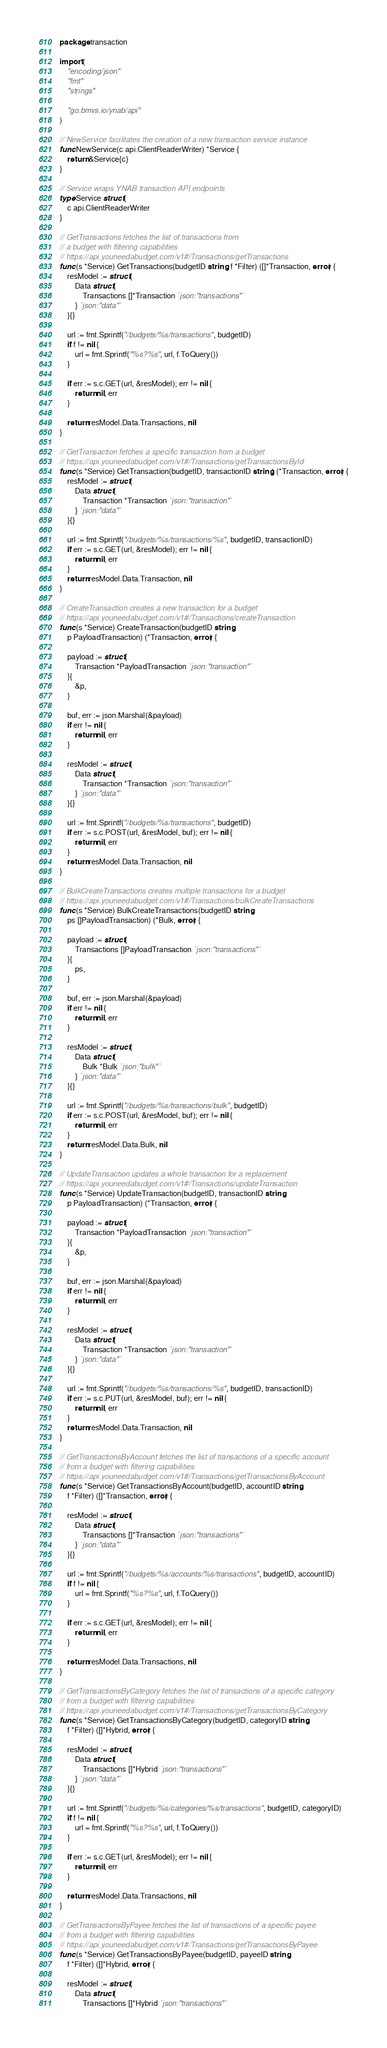Convert code to text. <code><loc_0><loc_0><loc_500><loc_500><_Go_>package transaction

import (
	"encoding/json"
	"fmt"
	"strings"

	"go.bmvs.io/ynab/api"
)

// NewService facilitates the creation of a new transaction service instance
func NewService(c api.ClientReaderWriter) *Service {
	return &Service{c}
}

// Service wraps YNAB transaction API endpoints
type Service struct {
	c api.ClientReaderWriter
}

// GetTransactions fetches the list of transactions from
// a budget with filtering capabilities
// https://api.youneedabudget.com/v1#/Transactions/getTransactions
func (s *Service) GetTransactions(budgetID string, f *Filter) ([]*Transaction, error) {
	resModel := struct {
		Data struct {
			Transactions []*Transaction `json:"transactions"`
		} `json:"data"`
	}{}

	url := fmt.Sprintf("/budgets/%s/transactions", budgetID)
	if f != nil {
		url = fmt.Sprintf("%s?%s", url, f.ToQuery())
	}

	if err := s.c.GET(url, &resModel); err != nil {
		return nil, err
	}

	return resModel.Data.Transactions, nil
}

// GetTransaction fetches a specific transaction from a budget
// https://api.youneedabudget.com/v1#/Transactions/getTransactionsById
func (s *Service) GetTransaction(budgetID, transactionID string) (*Transaction, error) {
	resModel := struct {
		Data struct {
			Transaction *Transaction `json:"transaction"`
		} `json:"data"`
	}{}

	url := fmt.Sprintf("/budgets/%s/transactions/%s", budgetID, transactionID)
	if err := s.c.GET(url, &resModel); err != nil {
		return nil, err
	}
	return resModel.Data.Transaction, nil
}

// CreateTransaction creates a new transaction for a budget
// https://api.youneedabudget.com/v1#/Transactions/createTransaction
func (s *Service) CreateTransaction(budgetID string,
	p PayloadTransaction) (*Transaction, error) {

	payload := struct {
		Transaction *PayloadTransaction `json:"transaction"`
	}{
		&p,
	}

	buf, err := json.Marshal(&payload)
	if err != nil {
		return nil, err
	}

	resModel := struct {
		Data struct {
			Transaction *Transaction `json:"transaction"`
		} `json:"data"`
	}{}

	url := fmt.Sprintf("/budgets/%s/transactions", budgetID)
	if err := s.c.POST(url, &resModel, buf); err != nil {
		return nil, err
	}
	return resModel.Data.Transaction, nil
}

// BulkCreateTransactions creates multiple transactions for a budget
// https://api.youneedabudget.com/v1#/Transactions/bulkCreateTransactions
func (s *Service) BulkCreateTransactions(budgetID string,
	ps []PayloadTransaction) (*Bulk, error) {

	payload := struct {
		Transactions []PayloadTransaction `json:"transactions"`
	}{
		ps,
	}

	buf, err := json.Marshal(&payload)
	if err != nil {
		return nil, err
	}

	resModel := struct {
		Data struct {
			Bulk *Bulk `json:"bulk"`
		} `json:"data"`
	}{}

	url := fmt.Sprintf("/budgets/%s/transactions/bulk", budgetID)
	if err := s.c.POST(url, &resModel, buf); err != nil {
		return nil, err
	}
	return resModel.Data.Bulk, nil
}

// UpdateTransaction updates a whole transaction for a replacement
// https://api.youneedabudget.com/v1#/Transactions/updateTransaction
func (s *Service) UpdateTransaction(budgetID, transactionID string,
	p PayloadTransaction) (*Transaction, error) {

	payload := struct {
		Transaction *PayloadTransaction `json:"transaction"`
	}{
		&p,
	}

	buf, err := json.Marshal(&payload)
	if err != nil {
		return nil, err
	}

	resModel := struct {
		Data struct {
			Transaction *Transaction `json:"transaction"`
		} `json:"data"`
	}{}

	url := fmt.Sprintf("/budgets/%s/transactions/%s", budgetID, transactionID)
	if err := s.c.PUT(url, &resModel, buf); err != nil {
		return nil, err
	}
	return resModel.Data.Transaction, nil
}

// GetTransactionsByAccount fetches the list of transactions of a specific account
// from a budget with filtering capabilities
// https://api.youneedabudget.com/v1#/Transactions/getTransactionsByAccount
func (s *Service) GetTransactionsByAccount(budgetID, accountID string,
	f *Filter) ([]*Transaction, error) {

	resModel := struct {
		Data struct {
			Transactions []*Transaction `json:"transactions"`
		} `json:"data"`
	}{}

	url := fmt.Sprintf("/budgets/%s/accounts/%s/transactions", budgetID, accountID)
	if f != nil {
		url = fmt.Sprintf("%s?%s", url, f.ToQuery())
	}

	if err := s.c.GET(url, &resModel); err != nil {
		return nil, err
	}

	return resModel.Data.Transactions, nil
}

// GetTransactionsByCategory fetches the list of transactions of a specific category
// from a budget with filtering capabilities
// https://api.youneedabudget.com/v1#/Transactions/getTransactionsByCategory
func (s *Service) GetTransactionsByCategory(budgetID, categoryID string,
	f *Filter) ([]*Hybrid, error) {

	resModel := struct {
		Data struct {
			Transactions []*Hybrid `json:"transactions"`
		} `json:"data"`
	}{}

	url := fmt.Sprintf("/budgets/%s/categories/%s/transactions", budgetID, categoryID)
	if f != nil {
		url = fmt.Sprintf("%s?%s", url, f.ToQuery())
	}

	if err := s.c.GET(url, &resModel); err != nil {
		return nil, err
	}

	return resModel.Data.Transactions, nil
}

// GetTransactionsByPayee fetches the list of transactions of a specific payee
// from a budget with filtering capabilities
// https://api.youneedabudget.com/v1#/Transactions/getTransactionsByPayee
func (s *Service) GetTransactionsByPayee(budgetID, payeeID string,
	f *Filter) ([]*Hybrid, error) {

	resModel := struct {
		Data struct {
			Transactions []*Hybrid `json:"transactions"`</code> 